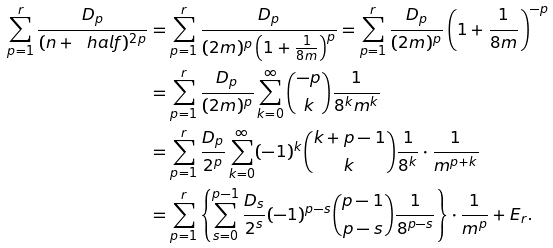<formula> <loc_0><loc_0><loc_500><loc_500>\sum _ { p = 1 } ^ { r } \frac { D _ { p } } { ( n + \ h a l f ) ^ { 2 p } } & = \sum _ { p = 1 } ^ { r } \frac { D _ { p } } { ( 2 m ) ^ { p } \left ( 1 + \frac { 1 } { 8 m } \right ) ^ { p } } = \sum _ { p = 1 } ^ { r } \frac { D _ { p } } { ( 2 m ) ^ { p } } \left ( 1 + \frac { 1 } { 8 m } \right ) ^ { - p } \\ & = \sum _ { p = 1 } ^ { r } \frac { D _ { p } } { ( 2 m ) ^ { p } } \sum _ { k = 0 } ^ { \infty } \binom { - p } { k } \frac { 1 } { 8 ^ { k } m ^ { k } } \\ & = \sum _ { p = 1 } ^ { r } \frac { D _ { p } } { 2 ^ { p } } \sum _ { k = 0 } ^ { \infty } ( - 1 ) ^ { k } \binom { k + p - 1 } { k } \frac { 1 } { 8 ^ { k } } \cdot \frac { 1 } { m ^ { p + k } } \\ & = \sum _ { p = 1 } ^ { r } \left \{ \sum _ { s = 0 } ^ { p - 1 } \frac { D _ { s } } { 2 ^ { s } } ( - 1 ) ^ { p - s } \binom { p - 1 } { p - s } \frac { 1 } { 8 ^ { p - s } } \right \} \cdot \frac { 1 } { m ^ { p } } + E _ { r } .</formula> 